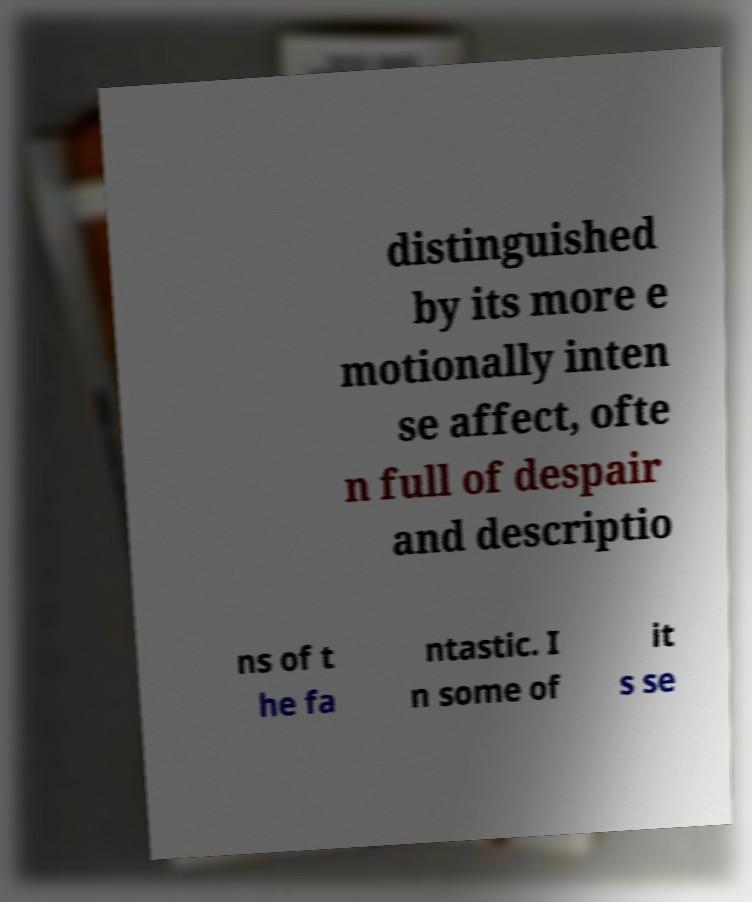I need the written content from this picture converted into text. Can you do that? distinguished by its more e motionally inten se affect, ofte n full of despair and descriptio ns of t he fa ntastic. I n some of it s se 